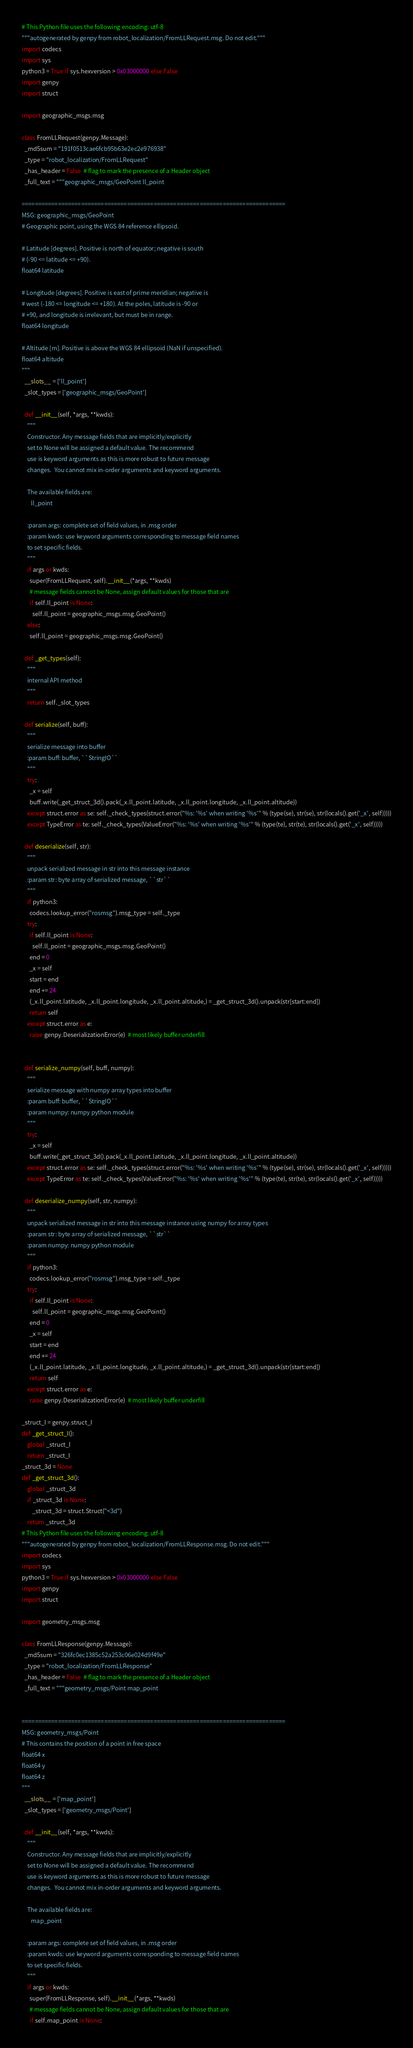<code> <loc_0><loc_0><loc_500><loc_500><_Python_># This Python file uses the following encoding: utf-8
"""autogenerated by genpy from robot_localization/FromLLRequest.msg. Do not edit."""
import codecs
import sys
python3 = True if sys.hexversion > 0x03000000 else False
import genpy
import struct

import geographic_msgs.msg

class FromLLRequest(genpy.Message):
  _md5sum = "191f0513cae6fcb95b63e2ec2e976938"
  _type = "robot_localization/FromLLRequest"
  _has_header = False  # flag to mark the presence of a Header object
  _full_text = """geographic_msgs/GeoPoint ll_point

================================================================================
MSG: geographic_msgs/GeoPoint
# Geographic point, using the WGS 84 reference ellipsoid.

# Latitude [degrees]. Positive is north of equator; negative is south
# (-90 <= latitude <= +90).
float64 latitude

# Longitude [degrees]. Positive is east of prime meridian; negative is
# west (-180 <= longitude <= +180). At the poles, latitude is -90 or
# +90, and longitude is irrelevant, but must be in range.
float64 longitude

# Altitude [m]. Positive is above the WGS 84 ellipsoid (NaN if unspecified).
float64 altitude
"""
  __slots__ = ['ll_point']
  _slot_types = ['geographic_msgs/GeoPoint']

  def __init__(self, *args, **kwds):
    """
    Constructor. Any message fields that are implicitly/explicitly
    set to None will be assigned a default value. The recommend
    use is keyword arguments as this is more robust to future message
    changes.  You cannot mix in-order arguments and keyword arguments.

    The available fields are:
       ll_point

    :param args: complete set of field values, in .msg order
    :param kwds: use keyword arguments corresponding to message field names
    to set specific fields.
    """
    if args or kwds:
      super(FromLLRequest, self).__init__(*args, **kwds)
      # message fields cannot be None, assign default values for those that are
      if self.ll_point is None:
        self.ll_point = geographic_msgs.msg.GeoPoint()
    else:
      self.ll_point = geographic_msgs.msg.GeoPoint()

  def _get_types(self):
    """
    internal API method
    """
    return self._slot_types

  def serialize(self, buff):
    """
    serialize message into buffer
    :param buff: buffer, ``StringIO``
    """
    try:
      _x = self
      buff.write(_get_struct_3d().pack(_x.ll_point.latitude, _x.ll_point.longitude, _x.ll_point.altitude))
    except struct.error as se: self._check_types(struct.error("%s: '%s' when writing '%s'" % (type(se), str(se), str(locals().get('_x', self)))))
    except TypeError as te: self._check_types(ValueError("%s: '%s' when writing '%s'" % (type(te), str(te), str(locals().get('_x', self)))))

  def deserialize(self, str):
    """
    unpack serialized message in str into this message instance
    :param str: byte array of serialized message, ``str``
    """
    if python3:
      codecs.lookup_error("rosmsg").msg_type = self._type
    try:
      if self.ll_point is None:
        self.ll_point = geographic_msgs.msg.GeoPoint()
      end = 0
      _x = self
      start = end
      end += 24
      (_x.ll_point.latitude, _x.ll_point.longitude, _x.ll_point.altitude,) = _get_struct_3d().unpack(str[start:end])
      return self
    except struct.error as e:
      raise genpy.DeserializationError(e)  # most likely buffer underfill


  def serialize_numpy(self, buff, numpy):
    """
    serialize message with numpy array types into buffer
    :param buff: buffer, ``StringIO``
    :param numpy: numpy python module
    """
    try:
      _x = self
      buff.write(_get_struct_3d().pack(_x.ll_point.latitude, _x.ll_point.longitude, _x.ll_point.altitude))
    except struct.error as se: self._check_types(struct.error("%s: '%s' when writing '%s'" % (type(se), str(se), str(locals().get('_x', self)))))
    except TypeError as te: self._check_types(ValueError("%s: '%s' when writing '%s'" % (type(te), str(te), str(locals().get('_x', self)))))

  def deserialize_numpy(self, str, numpy):
    """
    unpack serialized message in str into this message instance using numpy for array types
    :param str: byte array of serialized message, ``str``
    :param numpy: numpy python module
    """
    if python3:
      codecs.lookup_error("rosmsg").msg_type = self._type
    try:
      if self.ll_point is None:
        self.ll_point = geographic_msgs.msg.GeoPoint()
      end = 0
      _x = self
      start = end
      end += 24
      (_x.ll_point.latitude, _x.ll_point.longitude, _x.ll_point.altitude,) = _get_struct_3d().unpack(str[start:end])
      return self
    except struct.error as e:
      raise genpy.DeserializationError(e)  # most likely buffer underfill

_struct_I = genpy.struct_I
def _get_struct_I():
    global _struct_I
    return _struct_I
_struct_3d = None
def _get_struct_3d():
    global _struct_3d
    if _struct_3d is None:
        _struct_3d = struct.Struct("<3d")
    return _struct_3d
# This Python file uses the following encoding: utf-8
"""autogenerated by genpy from robot_localization/FromLLResponse.msg. Do not edit."""
import codecs
import sys
python3 = True if sys.hexversion > 0x03000000 else False
import genpy
import struct

import geometry_msgs.msg

class FromLLResponse(genpy.Message):
  _md5sum = "326fc0ec1385c52a253c06e024d9f49e"
  _type = "robot_localization/FromLLResponse"
  _has_header = False  # flag to mark the presence of a Header object
  _full_text = """geometry_msgs/Point map_point


================================================================================
MSG: geometry_msgs/Point
# This contains the position of a point in free space
float64 x
float64 y
float64 z
"""
  __slots__ = ['map_point']
  _slot_types = ['geometry_msgs/Point']

  def __init__(self, *args, **kwds):
    """
    Constructor. Any message fields that are implicitly/explicitly
    set to None will be assigned a default value. The recommend
    use is keyword arguments as this is more robust to future message
    changes.  You cannot mix in-order arguments and keyword arguments.

    The available fields are:
       map_point

    :param args: complete set of field values, in .msg order
    :param kwds: use keyword arguments corresponding to message field names
    to set specific fields.
    """
    if args or kwds:
      super(FromLLResponse, self).__init__(*args, **kwds)
      # message fields cannot be None, assign default values for those that are
      if self.map_point is None:</code> 